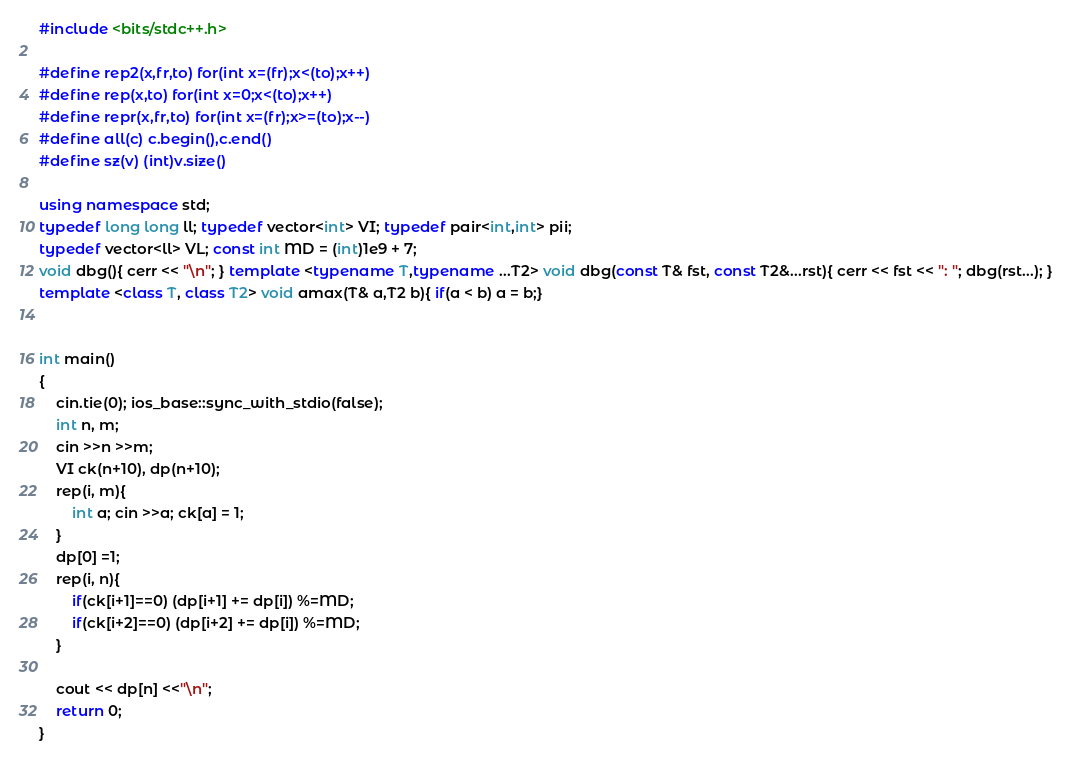<code> <loc_0><loc_0><loc_500><loc_500><_C++_>#include <bits/stdc++.h>

#define rep2(x,fr,to) for(int x=(fr);x<(to);x++)
#define rep(x,to) for(int x=0;x<(to);x++)
#define repr(x,fr,to) for(int x=(fr);x>=(to);x--)
#define all(c) c.begin(),c.end()
#define sz(v) (int)v.size()

using namespace std;
typedef long long ll; typedef vector<int> VI; typedef pair<int,int> pii;
typedef vector<ll> VL; const int MD = (int)1e9 + 7;
void dbg(){ cerr << "\n"; } template <typename T,typename ...T2> void dbg(const T& fst, const T2&...rst){ cerr << fst << ": "; dbg(rst...); }
template <class T, class T2> void amax(T& a,T2 b){ if(a < b) a = b;}


int main()
{
	cin.tie(0); ios_base::sync_with_stdio(false);
	int n, m;
	cin >>n >>m;
	VI ck(n+10), dp(n+10);
	rep(i, m){
		int a; cin >>a; ck[a] = 1;
	}
	dp[0] =1;
	rep(i, n){
		if(ck[i+1]==0) (dp[i+1] += dp[i]) %=MD;
		if(ck[i+2]==0) (dp[i+2] += dp[i]) %=MD;
	}
	
	cout << dp[n] <<"\n";
	return 0;
}
</code> 